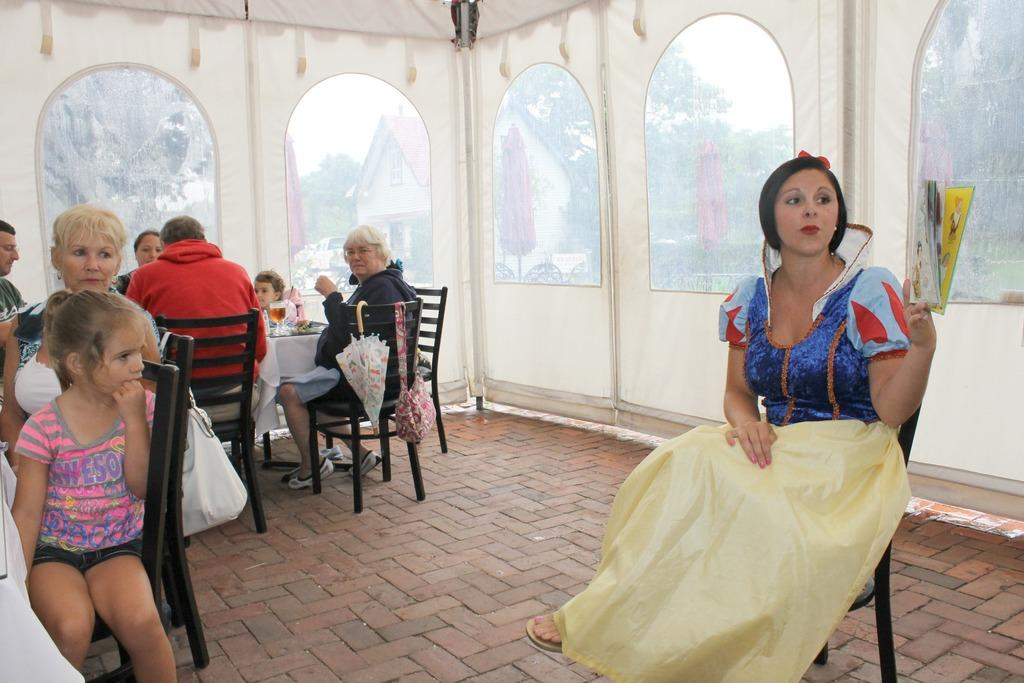What is the main activity of the people in the image? The group of people is sitting in chairs. What is in front of the group of people? There is a table in front of the group of people. Can you describe the woman in the image? The woman is sitting in a chair and holding a book. Where is the woman located in the image? The woman is in the right corner of the image. What type of hook is the woman using to read the book? There is no mention of a hook in the image or the provided facts. 